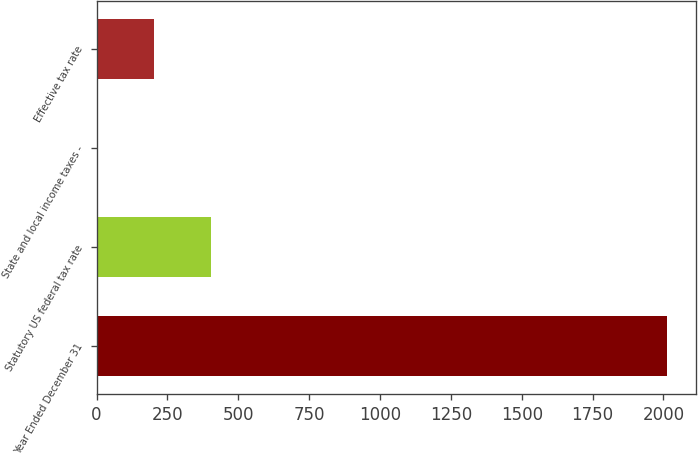Convert chart to OTSL. <chart><loc_0><loc_0><loc_500><loc_500><bar_chart><fcel>Year Ended December 31<fcel>Statutory US federal tax rate<fcel>State and local income taxes -<fcel>Effective tax rate<nl><fcel>2013<fcel>403.4<fcel>1<fcel>202.2<nl></chart> 